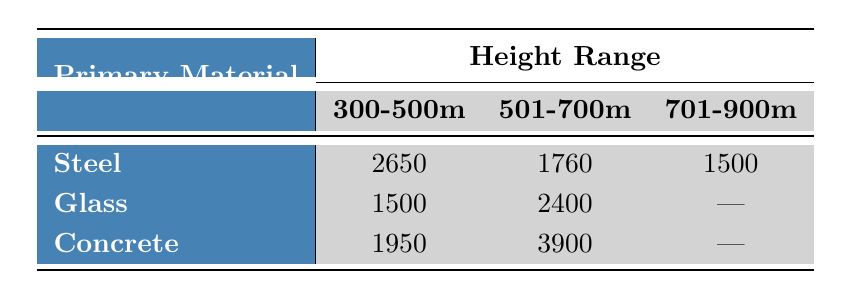What is the total construction cost for skyscrapers made of Steel in the height range of 300-500 meters? The table shows that the cost for Steel in the 300-500 meters height range is 2650 million USD.
Answer: 2650 million USD What is the construction cost of the tallest skyscraper listed? The tallest skyscraper is Burj Khalifa, which has a construction cost of 1500 million USD. It falls into the height range of 701-900 meters.
Answer: 1500 million USD Is the construction cost of skyscrapers made primarily of Glass in the 501-700 meters height range higher than those made of Steel in the same range? The cost for Glass in the 501-700 meters range is 2400 million USD, while for Steel, it is 1760 million USD. Since 2400 is greater than 1760, the statement is true.
Answer: Yes What is the average cost of skyscrapers in the height range of 300-500 meters across all primary materials? To find the average: add the costs for Steel (2650 million), Glass (1500 million), and Concrete (1950 million), then divide by three. The total is 2650 + 1500 + 1950 = 6100 million USD, and the average is 6100/3 = 2033.33 million USD.
Answer: 2033.33 million USD Which primary material has the highest construction cost in the height range of 501-700 meters? The costs in the 501-700 meters range are 1760 million USD for Steel, 2400 million USD for Glass, and 3900 million USD for Concrete. Since 3900 million is the highest, the answer is Concrete.
Answer: Concrete What is the cost difference between the primary materials Steel and Concrete in the height range of 300-500 meters? The cost for Steel is 2650 million USD, and for Concrete, it is 1950 million USD. To find the difference, subtract 1950 from 2650, which yields 700 million USD.
Answer: 700 million USD Are there any skyscrapers in the 701-900 meters height range that use Concrete as a primary material? According to the table, only Burj Khalifa, with Steel as its primary material, falls in the 701-900 meters range. Therefore, there are no skyscrapers using Concrete in this height range.
Answer: No What is the cost to height ratio (in million USD per meter) for the Shanghai Tower? The cost for Shanghai Tower is 2400 million USD, and its height is 632 meters. To find the ratio, divide 2400 by 632, resulting in approximately 3.79 million USD per meter.
Answer: 3.79 million USD 